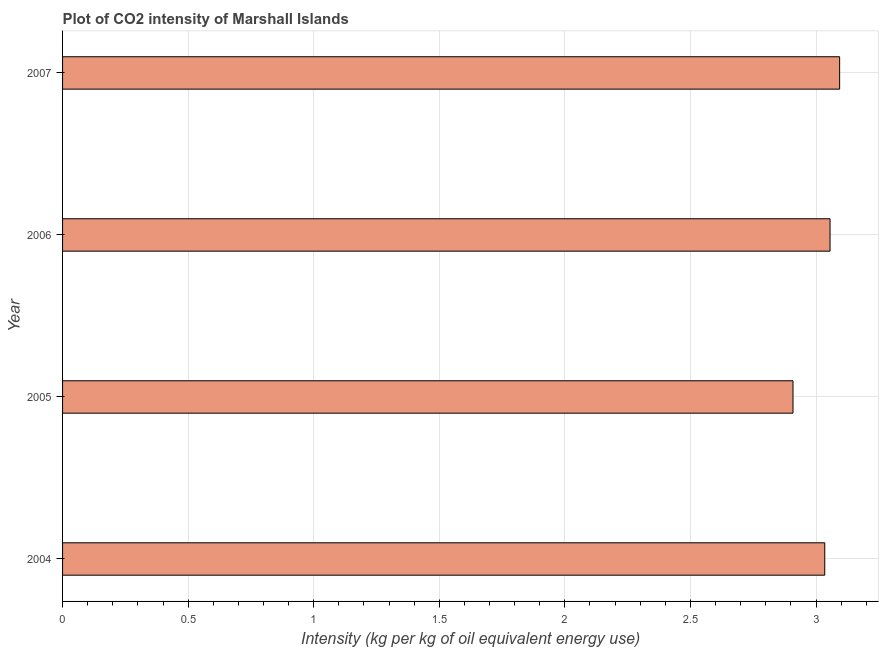Does the graph contain grids?
Give a very brief answer. Yes. What is the title of the graph?
Keep it short and to the point. Plot of CO2 intensity of Marshall Islands. What is the label or title of the X-axis?
Ensure brevity in your answer.  Intensity (kg per kg of oil equivalent energy use). What is the co2 intensity in 2006?
Offer a very short reply. 3.06. Across all years, what is the maximum co2 intensity?
Offer a terse response. 3.09. Across all years, what is the minimum co2 intensity?
Your answer should be compact. 2.91. In which year was the co2 intensity maximum?
Make the answer very short. 2007. In which year was the co2 intensity minimum?
Your answer should be very brief. 2005. What is the sum of the co2 intensity?
Offer a very short reply. 12.09. What is the difference between the co2 intensity in 2005 and 2007?
Offer a terse response. -0.19. What is the average co2 intensity per year?
Give a very brief answer. 3.02. What is the median co2 intensity?
Keep it short and to the point. 3.05. In how many years, is the co2 intensity greater than 0.1 kg?
Make the answer very short. 4. Do a majority of the years between 2007 and 2004 (inclusive) have co2 intensity greater than 2.3 kg?
Provide a succinct answer. Yes. What is the ratio of the co2 intensity in 2004 to that in 2005?
Make the answer very short. 1.04. Is the difference between the co2 intensity in 2004 and 2007 greater than the difference between any two years?
Your answer should be compact. No. What is the difference between the highest and the second highest co2 intensity?
Give a very brief answer. 0.04. Is the sum of the co2 intensity in 2004 and 2005 greater than the maximum co2 intensity across all years?
Keep it short and to the point. Yes. What is the difference between the highest and the lowest co2 intensity?
Give a very brief answer. 0.19. How many bars are there?
Keep it short and to the point. 4. Are all the bars in the graph horizontal?
Give a very brief answer. Yes. How many years are there in the graph?
Make the answer very short. 4. What is the difference between two consecutive major ticks on the X-axis?
Your answer should be compact. 0.5. What is the Intensity (kg per kg of oil equivalent energy use) of 2004?
Offer a very short reply. 3.03. What is the Intensity (kg per kg of oil equivalent energy use) of 2005?
Offer a terse response. 2.91. What is the Intensity (kg per kg of oil equivalent energy use) in 2006?
Provide a short and direct response. 3.06. What is the Intensity (kg per kg of oil equivalent energy use) of 2007?
Make the answer very short. 3.09. What is the difference between the Intensity (kg per kg of oil equivalent energy use) in 2004 and 2005?
Give a very brief answer. 0.13. What is the difference between the Intensity (kg per kg of oil equivalent energy use) in 2004 and 2006?
Make the answer very short. -0.02. What is the difference between the Intensity (kg per kg of oil equivalent energy use) in 2004 and 2007?
Keep it short and to the point. -0.06. What is the difference between the Intensity (kg per kg of oil equivalent energy use) in 2005 and 2006?
Provide a short and direct response. -0.15. What is the difference between the Intensity (kg per kg of oil equivalent energy use) in 2005 and 2007?
Offer a very short reply. -0.19. What is the difference between the Intensity (kg per kg of oil equivalent energy use) in 2006 and 2007?
Keep it short and to the point. -0.04. What is the ratio of the Intensity (kg per kg of oil equivalent energy use) in 2004 to that in 2005?
Your answer should be very brief. 1.04. What is the ratio of the Intensity (kg per kg of oil equivalent energy use) in 2004 to that in 2006?
Make the answer very short. 0.99. What is the ratio of the Intensity (kg per kg of oil equivalent energy use) in 2004 to that in 2007?
Offer a terse response. 0.98. What is the ratio of the Intensity (kg per kg of oil equivalent energy use) in 2005 to that in 2006?
Offer a terse response. 0.95. What is the ratio of the Intensity (kg per kg of oil equivalent energy use) in 2006 to that in 2007?
Keep it short and to the point. 0.99. 